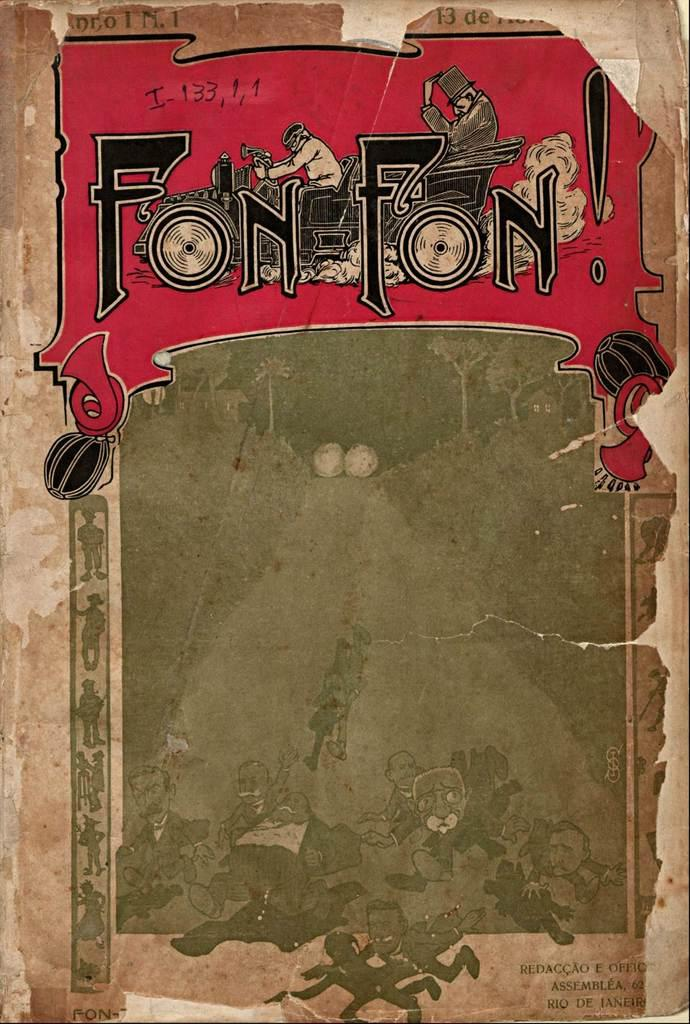<image>
Summarize the visual content of the image. Book cover with the words "Fon Fon" on it and a man driving a vehicle. 